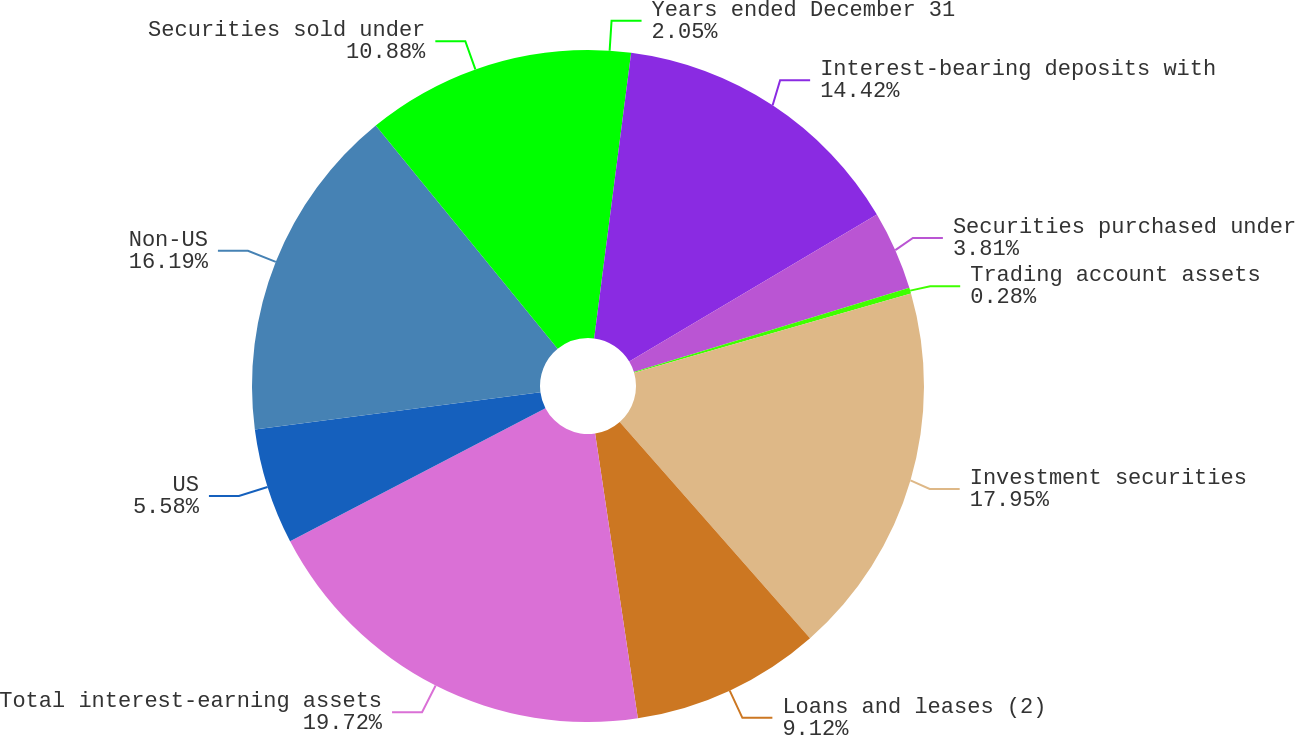<chart> <loc_0><loc_0><loc_500><loc_500><pie_chart><fcel>Years ended December 31<fcel>Interest-bearing deposits with<fcel>Securities purchased under<fcel>Trading account assets<fcel>Investment securities<fcel>Loans and leases (2)<fcel>Total interest-earning assets<fcel>US<fcel>Non-US<fcel>Securities sold under<nl><fcel>2.05%<fcel>14.42%<fcel>3.81%<fcel>0.28%<fcel>17.95%<fcel>9.12%<fcel>19.72%<fcel>5.58%<fcel>16.19%<fcel>10.88%<nl></chart> 